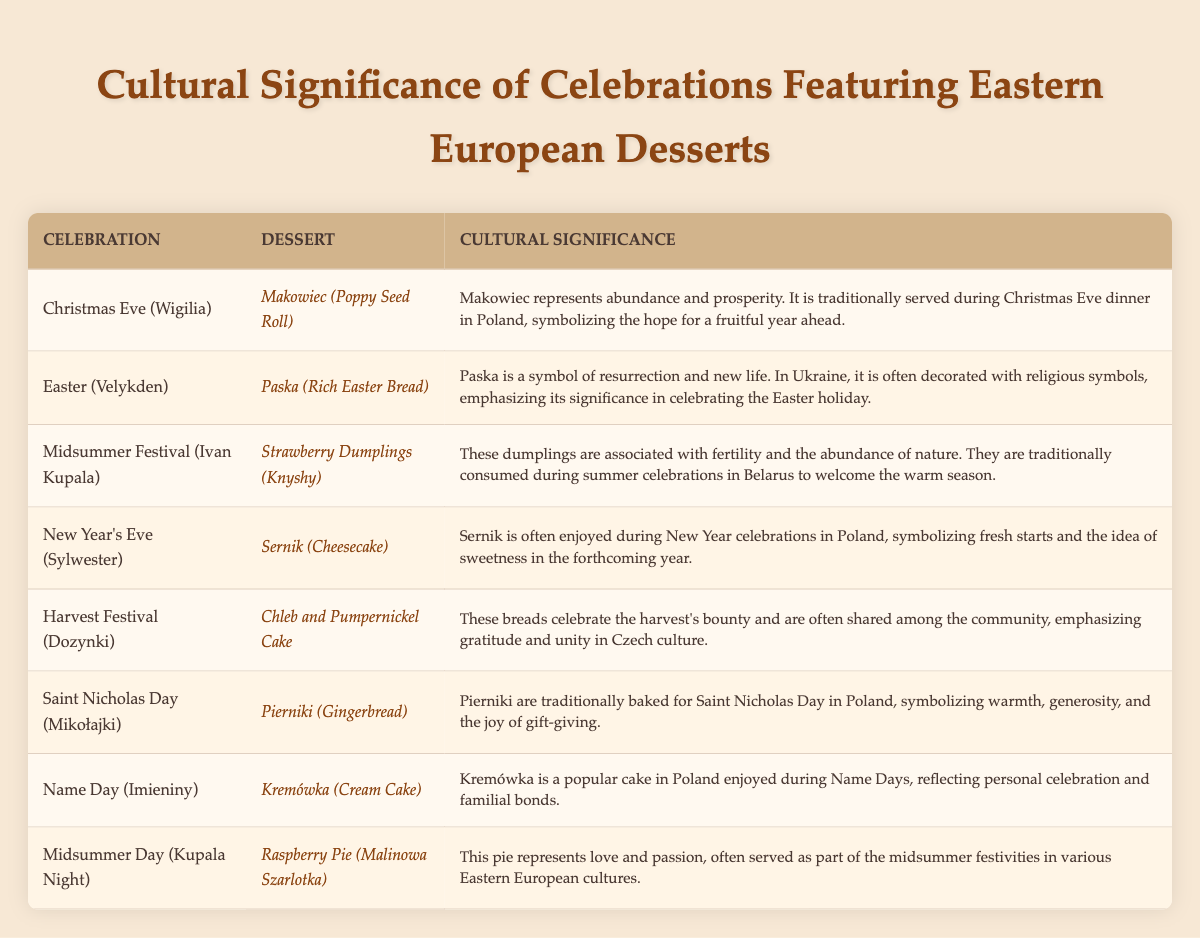What dessert is served during Christmas Eve (Wigilia)? The table lists the dessert associated with Christmas Eve (Wigilia) as Makowiec (Poppy Seed Roll).
Answer: Makowiec (Poppy Seed Roll) What is the cultural significance of Sernik (Cheesecake)? According to the table, Sernik is enjoyed during New Year celebrations and symbolizes fresh starts and the sweetness of the forthcoming year.
Answer: Fresh starts and sweetness Is Paska (Rich Easter Bread) associated with Easter celebrations? Yes, the table confirms that Paska is a dessert served during Easter (Velykden), indicating its association with the celebration.
Answer: Yes Which dessert represents love and passion? The table states that Raspberry Pie (Malinowa Szarlotka) is associated with love and passion during midsummer festivities.
Answer: Raspberry Pie (Malinowa Szarlotka) How many desserts are listed for celebrations in Belarus? The table lists two desserts related to celebrations in Belarus: Strawberry Dumplings (Knyshy) for Midsummer Festival (Ivan Kupala) and no other for other Belarus celebrations, so the total is one.
Answer: One What dessert symbolizes abundance and prosperity? The table specifies that Makowiec (Poppy Seed Roll) represents abundance and prosperity during Christmas Eve (Wigilia).
Answer: Makowiec (Poppy Seed Roll) Which celebration is associated with the dessert known for its decorated religious symbols? The table indicates that the celebration of Easter (Velykden) is associated with Paska, which is often decorated with religious symbols.
Answer: Easter (Velykden) How do the desserts for New Year's Eve and Christmas Eve differ in significance? New Year's Eve features Sernik, symbolizing fresh starts, while Christmas Eve features Makowiec, representing abundance and prosperity, indicating a focus on renewal vs. abundance.
Answer: Different focuses What is the main theme of desserts served during celebrations in Eastern European cultures? Most desserts reflect cultural values like abundance, resurrection, love, and familial bonds, showing a connection between food and cultural significance in celebrations.
Answer: Cultural values List all desserts that symbolize community and sharing. From the table, Chleb and Pumpernickel Cake during the Harvest Festival (Dozynki) emphasize gratitude and unity, thus representing community and sharing.
Answer: Chleb and Pumpernickel Cake 